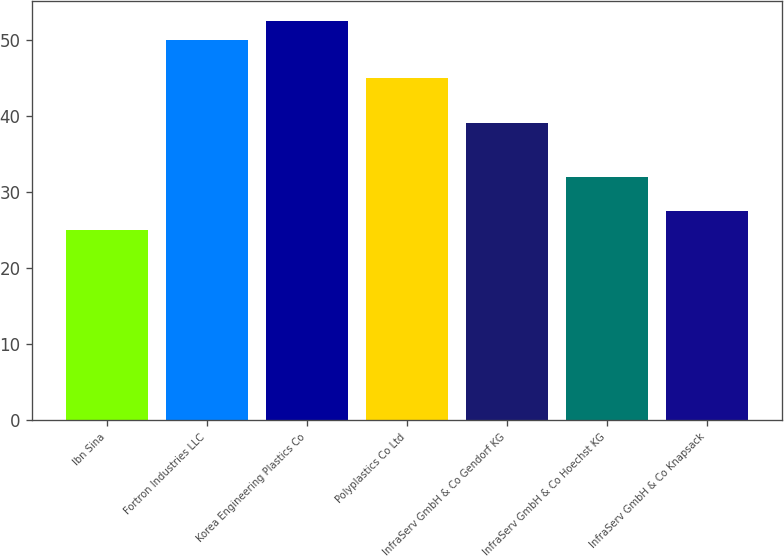Convert chart. <chart><loc_0><loc_0><loc_500><loc_500><bar_chart><fcel>Ibn Sina<fcel>Fortron Industries LLC<fcel>Korea Engineering Plastics Co<fcel>Polyplastics Co Ltd<fcel>InfraServ GmbH & Co Gendorf KG<fcel>InfraServ GmbH & Co Hoechst KG<fcel>InfraServ GmbH & Co Knapsack<nl><fcel>25<fcel>50<fcel>52.5<fcel>45<fcel>39<fcel>32<fcel>27.5<nl></chart> 